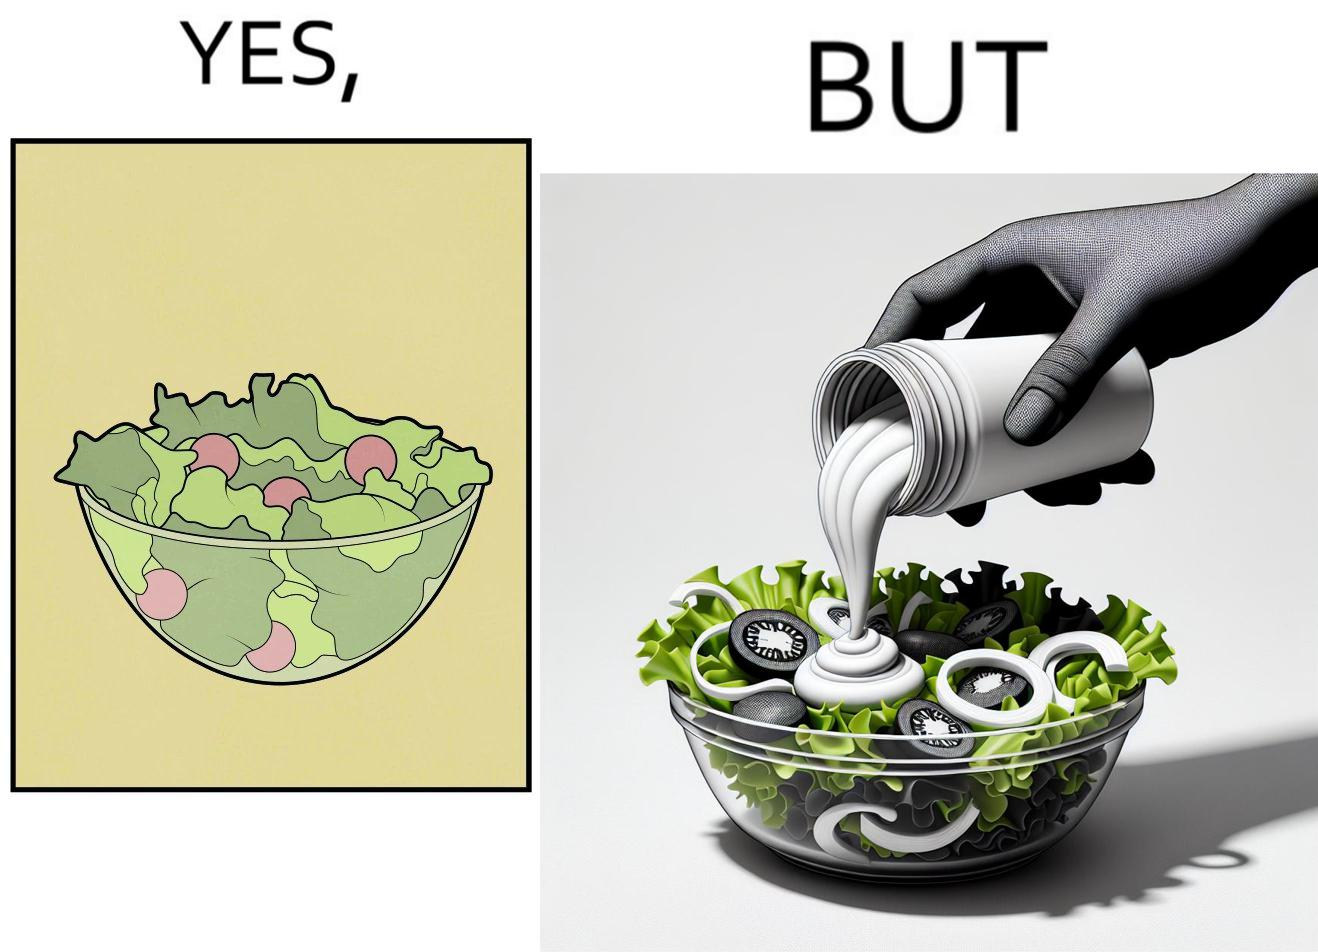What is shown in this image? The image is ironical, as salad in a bowl by itself is very healthy. However, when people have it with Mayonnaise sauce to improve the taste, it is not healthy anymore, and defeats the point of having nutrient-rich salad altogether. 